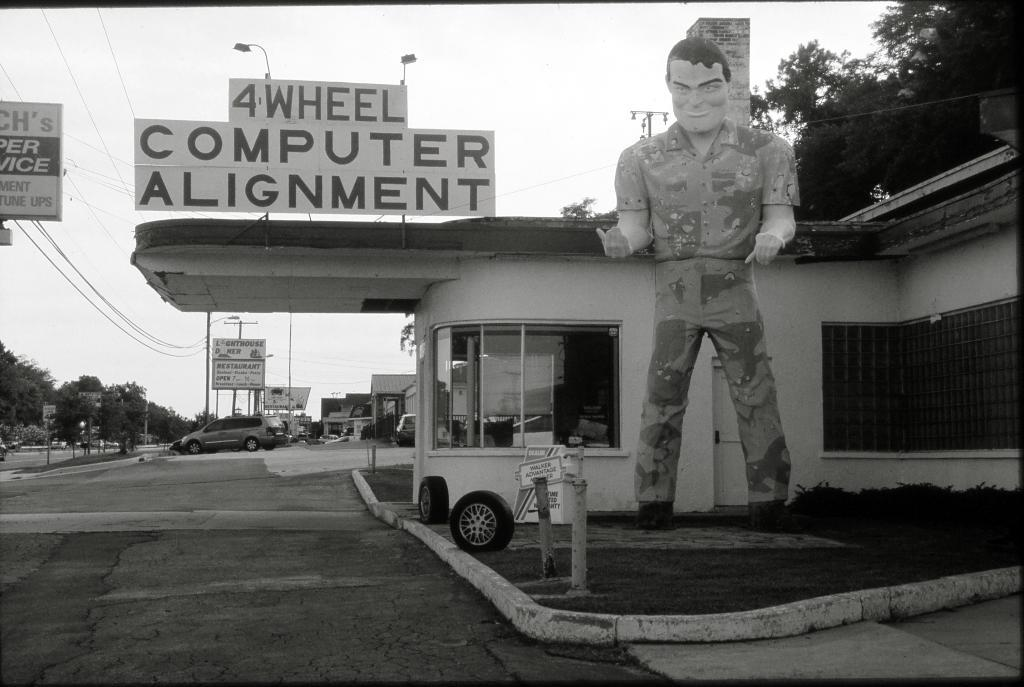What type of structures can be seen in the image? There are buildings in the image. What other natural elements are present in the image? There are trees in the image. Are there any signs or advertisements visible in the image? Yes, there are hoardings with text in the image. What type of lighting is present in the image? Pole lights are visible in the image. What else can be seen on the poles? Poles are present in the image. Is there any artwork or sculpture in the image? Yes, there is a statue of a man in the image. What objects are on the ground in the image? There are tires on the ground in the image. How would you describe the weather in the image? The sky is cloudy in the image. What type of toothpaste is being discussed in the image? There is no discussion or toothpaste present in the image. What caused the statue to fall in the image? There is no statue falling in the image, and no cause can be determined. 